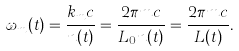Convert formula to latex. <formula><loc_0><loc_0><loc_500><loc_500>\omega _ { m } ( t ) = \frac { k _ { m } c } { n ( t ) } = \frac { 2 \pi m c } { L _ { 0 } n ( t ) } = \frac { 2 \pi m c } { L ( t ) } .</formula> 